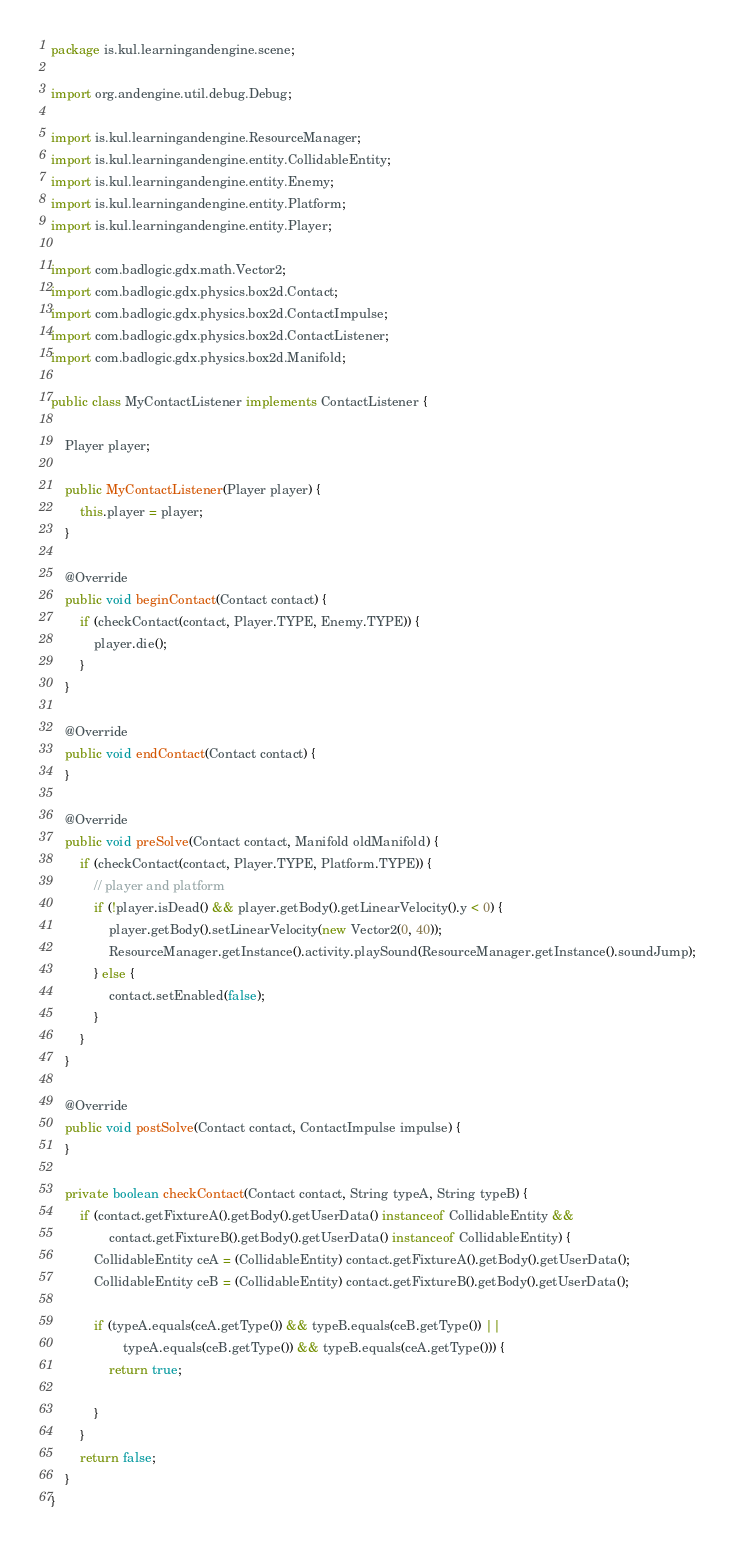Convert code to text. <code><loc_0><loc_0><loc_500><loc_500><_Java_>package is.kul.learningandengine.scene;

import org.andengine.util.debug.Debug;

import is.kul.learningandengine.ResourceManager;
import is.kul.learningandengine.entity.CollidableEntity;
import is.kul.learningandengine.entity.Enemy;
import is.kul.learningandengine.entity.Platform;
import is.kul.learningandengine.entity.Player;

import com.badlogic.gdx.math.Vector2;
import com.badlogic.gdx.physics.box2d.Contact;
import com.badlogic.gdx.physics.box2d.ContactImpulse;
import com.badlogic.gdx.physics.box2d.ContactListener;
import com.badlogic.gdx.physics.box2d.Manifold;

public class MyContactListener implements ContactListener {
	
	Player player;
	
	public MyContactListener(Player player) {
		this.player = player;
	}

	@Override
	public void beginContact(Contact contact) {
		if (checkContact(contact, Player.TYPE, Enemy.TYPE)) {
			player.die();
		}
	}

	@Override
	public void endContact(Contact contact) {
	}

	@Override
	public void preSolve(Contact contact, Manifold oldManifold) {
		if (checkContact(contact, Player.TYPE, Platform.TYPE)) {
			// player and platform
			if (!player.isDead() && player.getBody().getLinearVelocity().y < 0) {
				player.getBody().setLinearVelocity(new Vector2(0, 40));
				ResourceManager.getInstance().activity.playSound(ResourceManager.getInstance().soundJump);
			} else {
				contact.setEnabled(false);
			}			
		}
	}

	@Override
	public void postSolve(Contact contact, ContactImpulse impulse) {
	}

	private boolean checkContact(Contact contact, String typeA, String typeB) {
		if (contact.getFixtureA().getBody().getUserData() instanceof CollidableEntity &&
				contact.getFixtureB().getBody().getUserData() instanceof CollidableEntity) {
			CollidableEntity ceA = (CollidableEntity) contact.getFixtureA().getBody().getUserData();
			CollidableEntity ceB = (CollidableEntity) contact.getFixtureB().getBody().getUserData();
			
			if (typeA.equals(ceA.getType()) && typeB.equals(ceB.getType()) ||
					typeA.equals(ceB.getType()) && typeB.equals(ceA.getType())) {
				return true;
				
			}
		}
		return false;
	}
}
</code> 